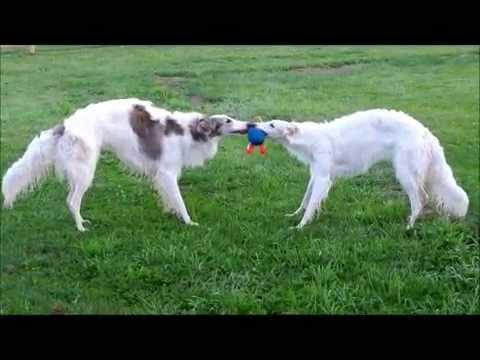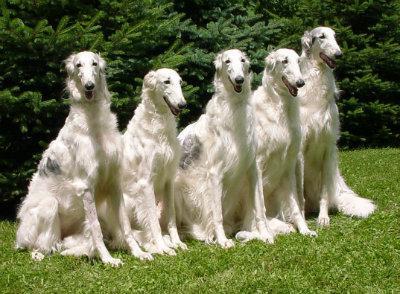The first image is the image on the left, the second image is the image on the right. Examine the images to the left and right. Is the description "There are two dogs in total." accurate? Answer yes or no. No. The first image is the image on the left, the second image is the image on the right. For the images displayed, is the sentence "One image includes at least twice as many hounds in the foreground as the other image." factually correct? Answer yes or no. Yes. The first image is the image on the left, the second image is the image on the right. For the images shown, is this caption "An image shows two hounds interacting face-to-face." true? Answer yes or no. Yes. The first image is the image on the left, the second image is the image on the right. Assess this claim about the two images: "Two dogs are facing each other in one of the images.". Correct or not? Answer yes or no. Yes. 